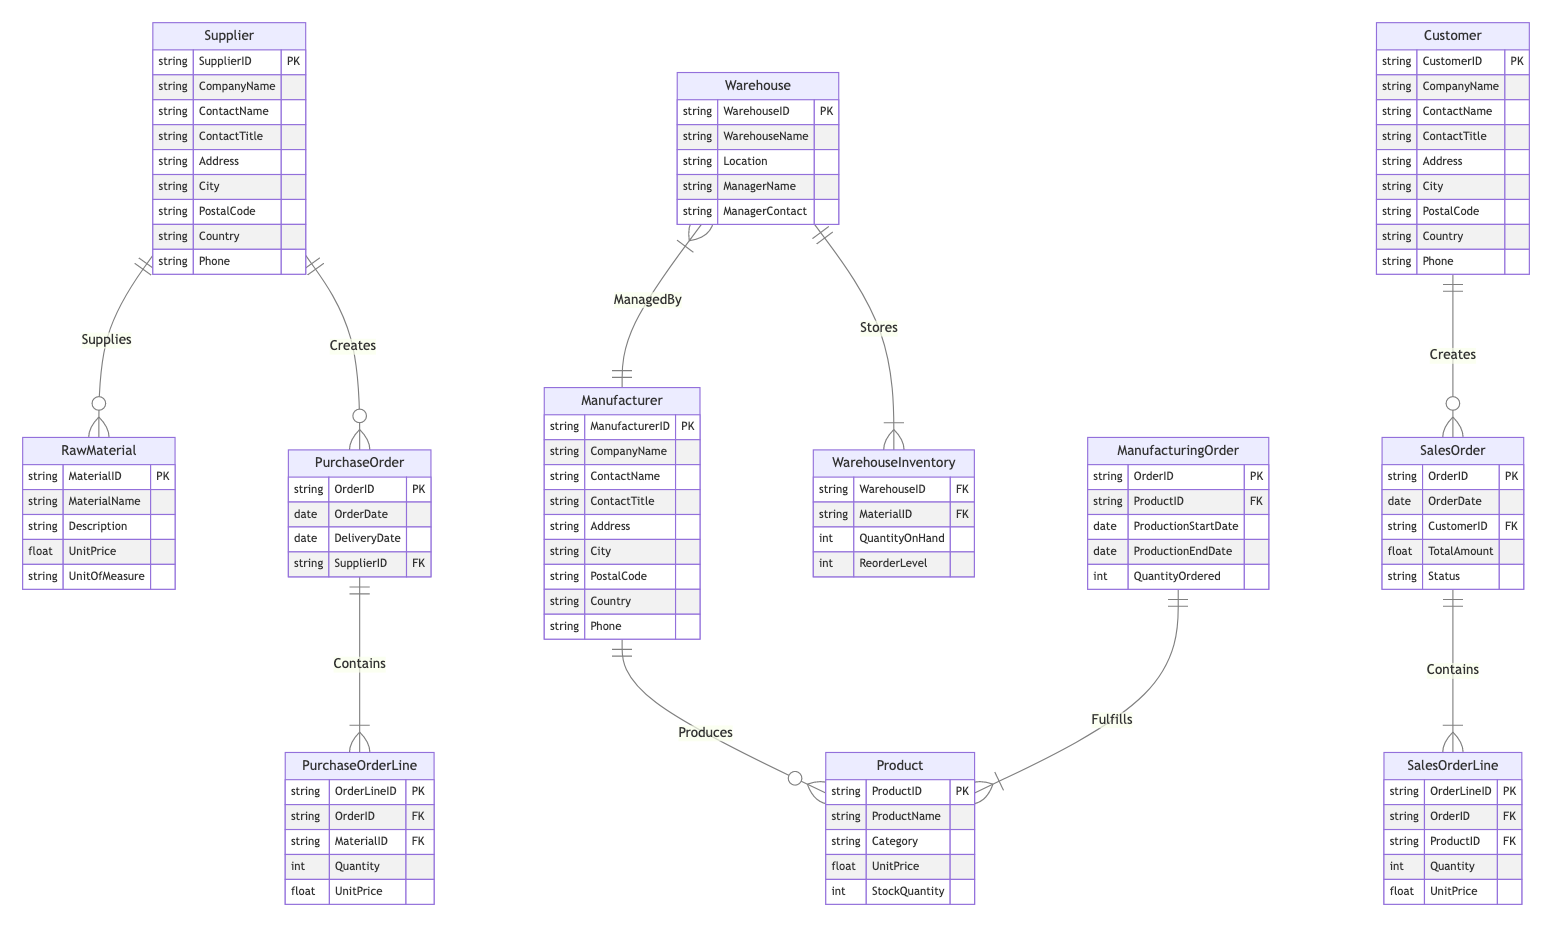What is the primary key of the Supplier entity? The primary key of the Supplier entity is SupplierID, as indicated by "PK" next to it in the diagram.
Answer: SupplierID How many entities are present in the diagram? By counting the distinct entities listed, there are 12 entities present in the diagram.
Answer: 12 What relationship connects Manufacturer and Product? The relationship that connects Manufacturer and Product is named "Produces," indicating that a manufacturer creates products.
Answer: Produces Which entity is responsible for managing a Warehouse? The entity responsible for managing a Warehouse is Manufacturer, as shown by the "ManagedBy" relationship indicating the management connection.
Answer: Manufacturer What is the unit of measure for RawMaterial? The unit of measure for RawMaterial is listed as "UnitOfMeasure" in the entity's attributes, meaning this is the attribute that defines it.
Answer: UnitOfMeasure Which entity creates a SalesOrder? The entity that creates a SalesOrder is Customer, as indicated by the "Creates" relationship linking Customer and SalesOrder.
Answer: Customer How many lines are contained in a PurchaseOrder? Each PurchaseOrder can contain multiple PurchaseOrderLine items, indicated by the "Contains" relationship; however, the exact number is not specified in the diagram.
Answer: Not specified What is the relationship type between Warehouse and WarehouseInventory? The relationship type between Warehouse and WarehouseInventory is "Stores," indicating that warehouses hold stock inventory of materials.
Answer: Stores Which entity connects with SalesOrderLine through a foreign key? The entity that connects with SalesOrderLine through a foreign key is SalesOrder, as indicated by the relationship "Contains," showing it holds the order lines.
Answer: SalesOrder What attribute of Product indicates its price? The attribute of Product that indicates its price is UnitPrice, which represents the cost assigned to each product.
Answer: UnitPrice 